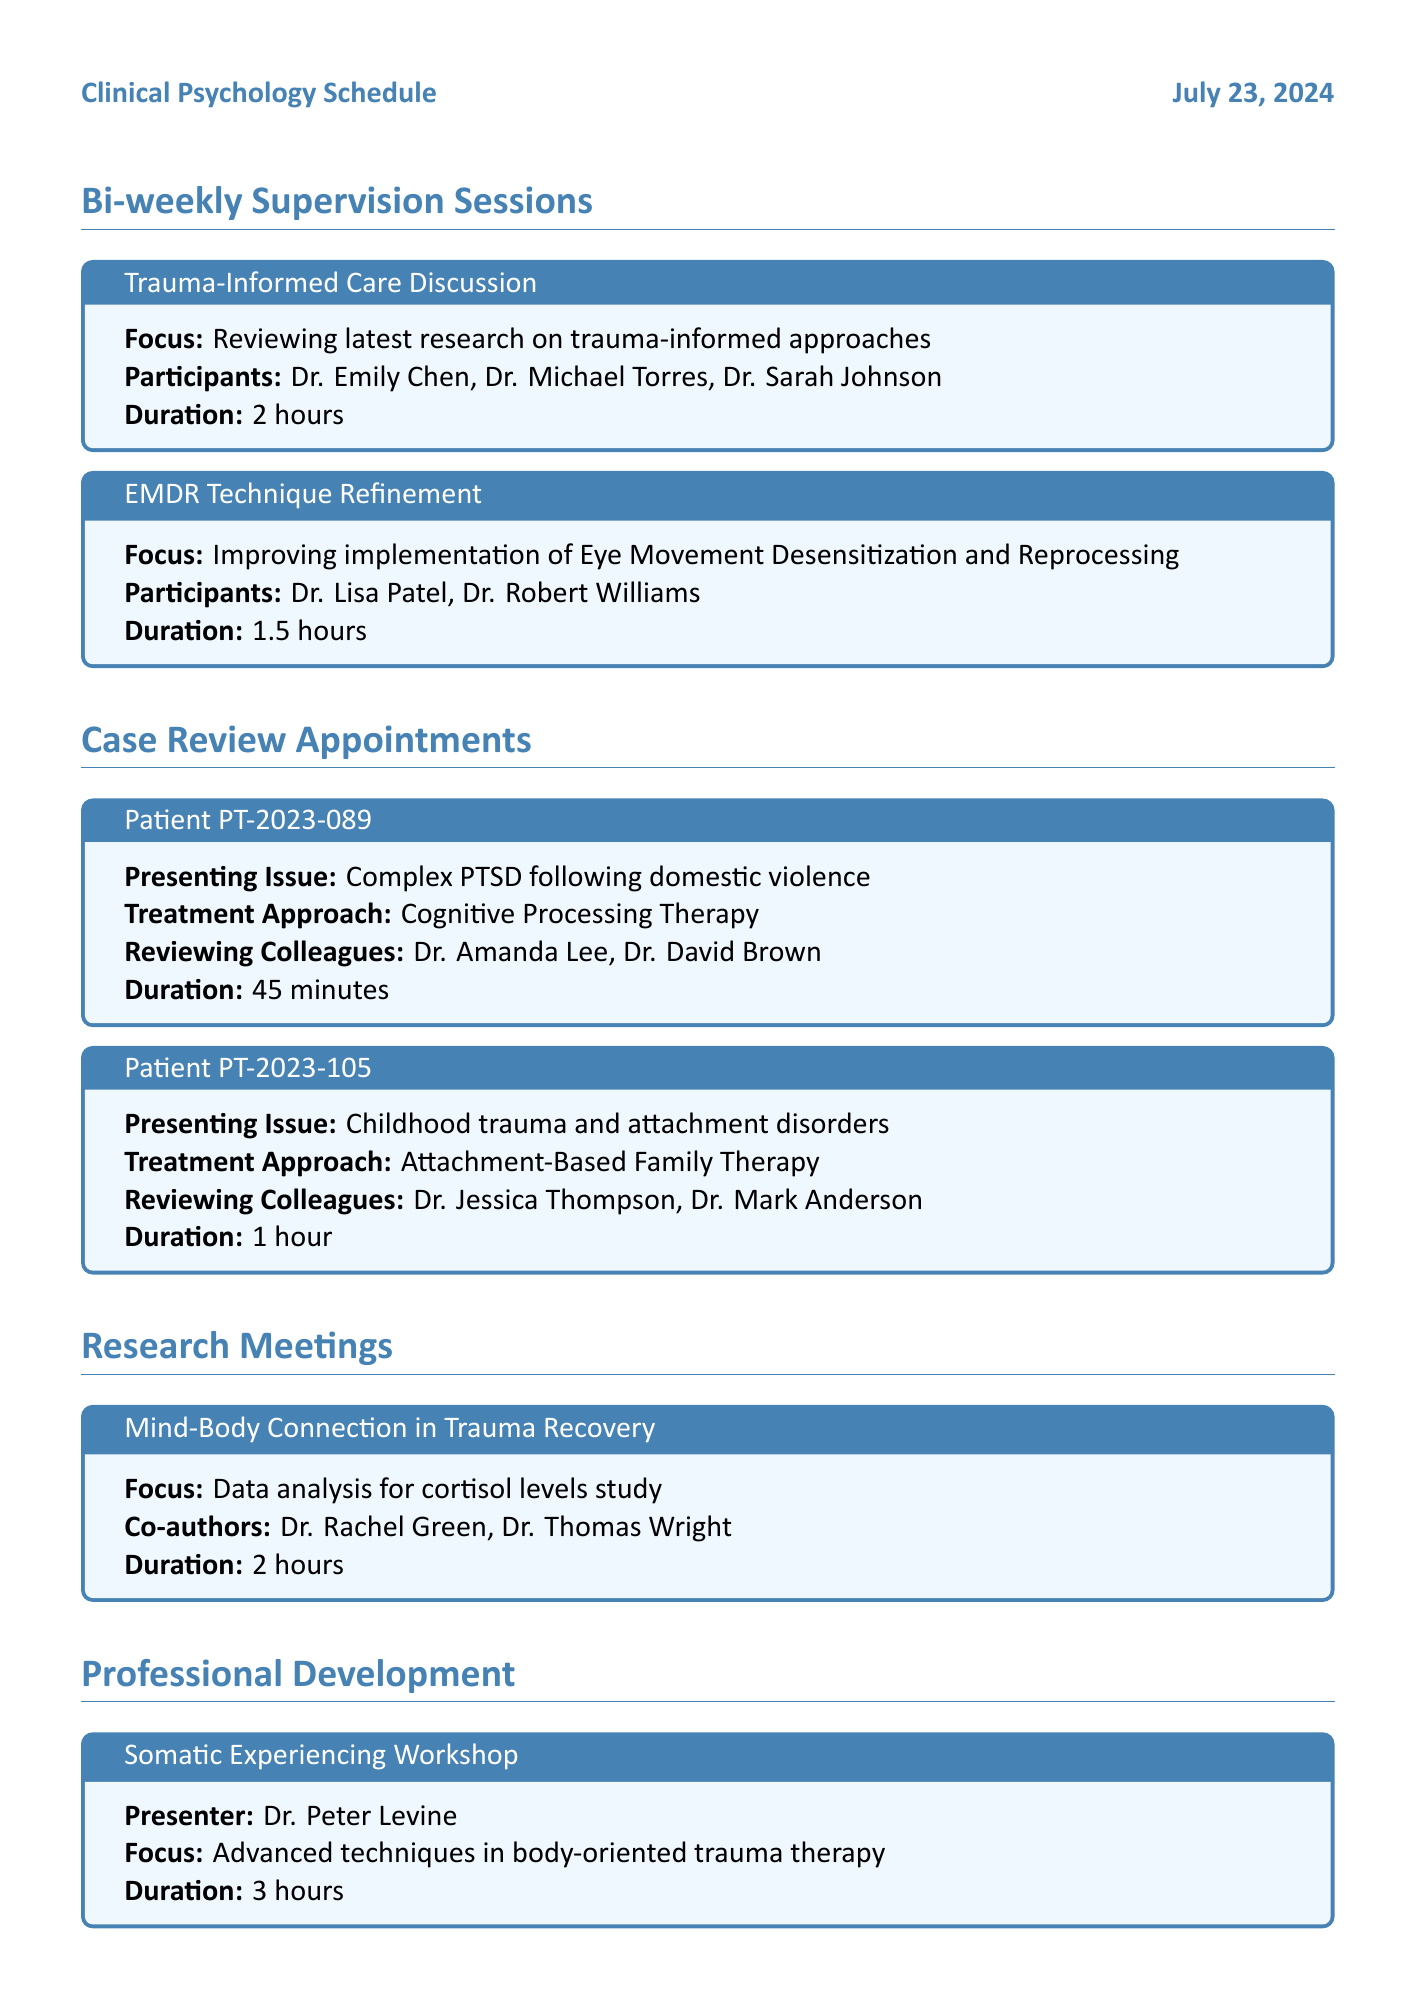What is the duration of the Trauma-Informed Care Discussion? The duration of the Trauma-Informed Care Discussion is listed in the document as 2 hours.
Answer: 2 hours Who are the participants in the EMDR Technique Refinement session? The document lists the participants in the EMDR Technique Refinement session as Dr. Lisa Patel and Dr. Robert Williams.
Answer: Dr. Lisa Patel, Dr. Robert Williams What is the presenting issue for Patient PT-2023-105? The presenting issue for Patient PT-2023-105 is specified in the document as childhood trauma and attachment disorders.
Answer: Childhood trauma and attachment disorders How long is the Difficult Case Discussion scheduled for? The document indicates that the Difficult Case Discussion is scheduled for 1 hour.
Answer: 1 hour What treatment approach is being used for Patient PT-2023-089? The treatment approach for Patient PT-2023-089 is cognitive processing therapy, as noted in the document.
Answer: Cognitive Processing Therapy How many colleagues are reviewing Patient PT-2023-089? The document states that two colleagues are reviewing Patient PT-2023-089.
Answer: 2 What is the focus of the Somatic Experiencing Workshop? The focus of the Somatic Experiencing Workshop is described in the document as advanced techniques in body-oriented trauma therapy.
Answer: Advanced techniques in body-oriented trauma therapy What is the title of the research meeting focusing on cortisol levels? The title of the research meeting is indicated in the document as "Mind-Body Connection in Trauma Recovery."
Answer: Mind-Body Connection in Trauma Recovery What is the duration for updating treatment plans for long-term patients? The duration for updating treatment plans for long-term patients is specified in the document as 2 hours.
Answer: 2 hours 